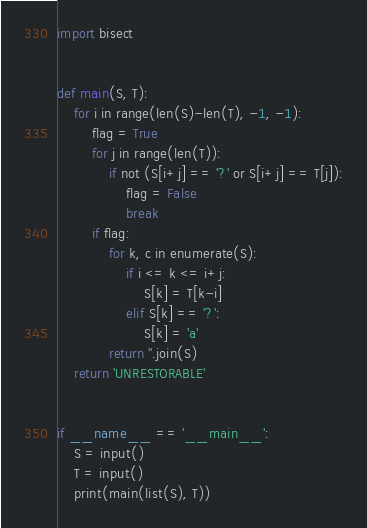Convert code to text. <code><loc_0><loc_0><loc_500><loc_500><_Python_>import bisect


def main(S, T):
    for i in range(len(S)-len(T), -1, -1):
        flag = True
        for j in range(len(T)):
            if not (S[i+j] == '?' or S[i+j] == T[j]):
                flag = False
                break
        if flag:
            for k, c in enumerate(S):
                if i <= k <= i+j:
                    S[k] = T[k-i]
                elif S[k] == '?':
                    S[k] = 'a'
            return ''.join(S)
    return 'UNRESTORABLE'


if __name__ == '__main__':
    S = input()
    T = input()
    print(main(list(S), T))</code> 